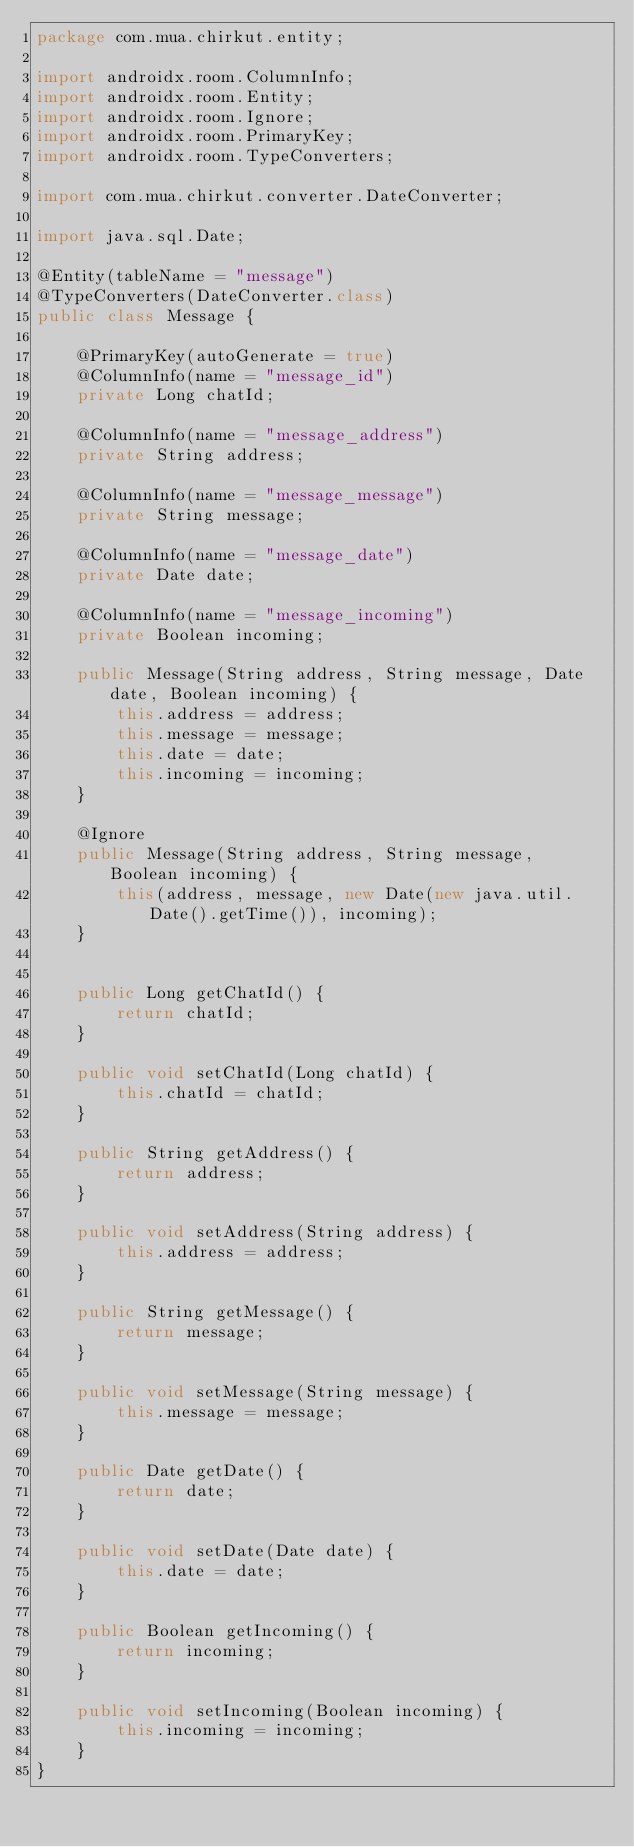Convert code to text. <code><loc_0><loc_0><loc_500><loc_500><_Java_>package com.mua.chirkut.entity;

import androidx.room.ColumnInfo;
import androidx.room.Entity;
import androidx.room.Ignore;
import androidx.room.PrimaryKey;
import androidx.room.TypeConverters;

import com.mua.chirkut.converter.DateConverter;

import java.sql.Date;

@Entity(tableName = "message")
@TypeConverters(DateConverter.class)
public class Message {

    @PrimaryKey(autoGenerate = true)
    @ColumnInfo(name = "message_id")
    private Long chatId;

    @ColumnInfo(name = "message_address")
    private String address;

    @ColumnInfo(name = "message_message")
    private String message;

    @ColumnInfo(name = "message_date")
    private Date date;

    @ColumnInfo(name = "message_incoming")
    private Boolean incoming;

    public Message(String address, String message, Date date, Boolean incoming) {
        this.address = address;
        this.message = message;
        this.date = date;
        this.incoming = incoming;
    }

    @Ignore
    public Message(String address, String message, Boolean incoming) {
        this(address, message, new Date(new java.util.Date().getTime()), incoming);
    }


    public Long getChatId() {
        return chatId;
    }

    public void setChatId(Long chatId) {
        this.chatId = chatId;
    }

    public String getAddress() {
        return address;
    }

    public void setAddress(String address) {
        this.address = address;
    }

    public String getMessage() {
        return message;
    }

    public void setMessage(String message) {
        this.message = message;
    }

    public Date getDate() {
        return date;
    }

    public void setDate(Date date) {
        this.date = date;
    }

    public Boolean getIncoming() {
        return incoming;
    }

    public void setIncoming(Boolean incoming) {
        this.incoming = incoming;
    }
}</code> 